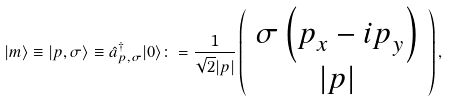Convert formula to latex. <formula><loc_0><loc_0><loc_500><loc_500>| m \rangle \equiv | p , \sigma \rangle \equiv \hat { a } ^ { \dag } _ { p , \sigma } | 0 \rangle \colon = \frac { 1 } { \sqrt { 2 } | p | } \left ( \begin{array} { c } \sigma \left ( p ^ { \ } _ { x } - { i } p ^ { \ } _ { y } \right ) \\ | p | \end{array} \right ) ,</formula> 